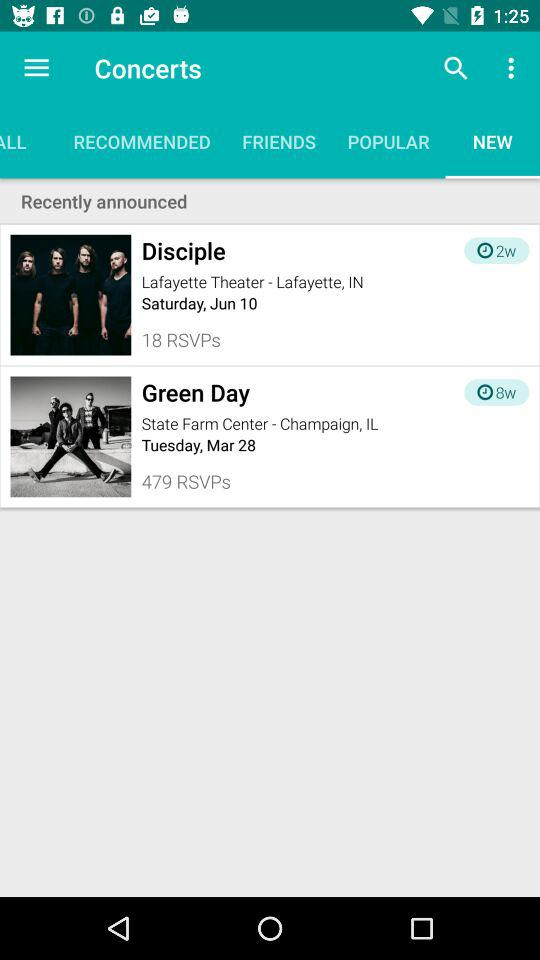How many RSVPs were there for the "Green Day" concert? There were 479 RSVPs for the "Green Day" concert. 